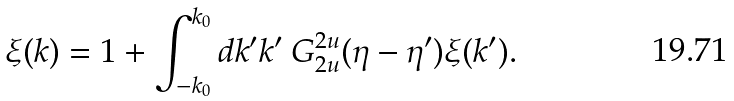Convert formula to latex. <formula><loc_0><loc_0><loc_500><loc_500>\xi ( k ) = 1 + \int _ { - k _ { 0 } } ^ { k _ { 0 } } d k ^ { \prime } k ^ { \prime } \ G _ { 2 u } ^ { 2 u } ( \eta - \eta ^ { \prime } ) \xi ( k ^ { \prime } ) .</formula> 